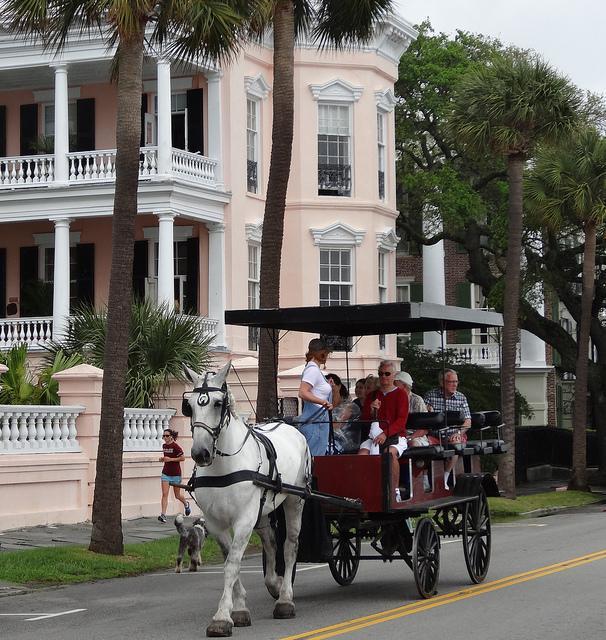How many people are there?
Give a very brief answer. 3. How many red fish kites are there?
Give a very brief answer. 0. 